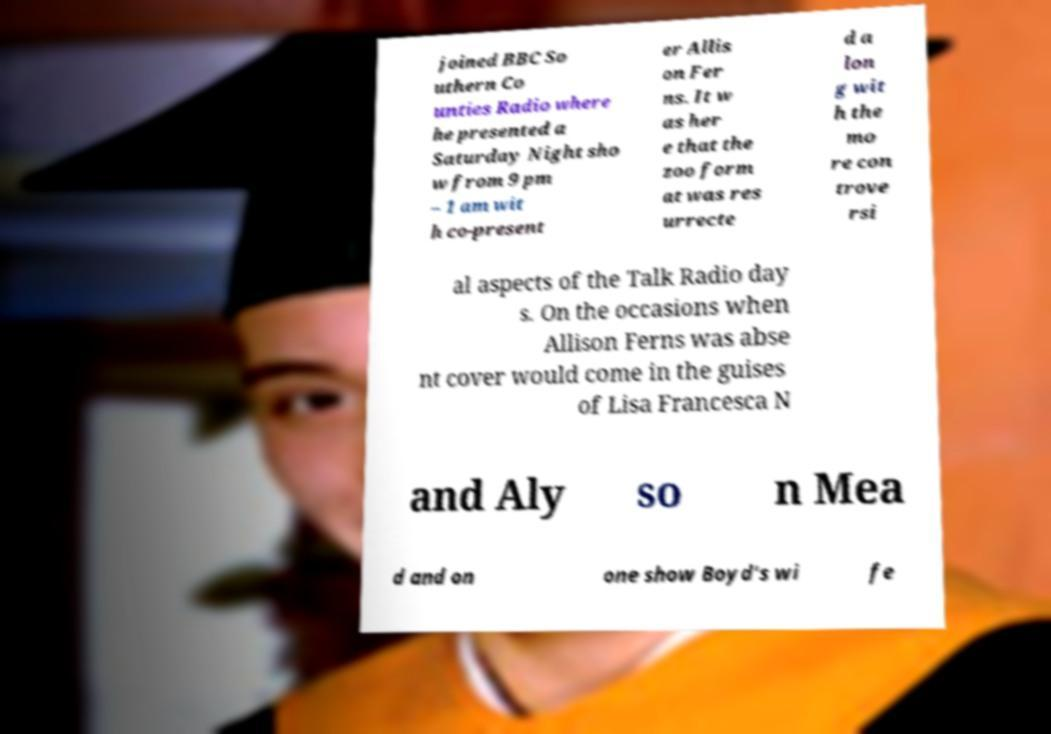Please read and relay the text visible in this image. What does it say? joined BBC So uthern Co unties Radio where he presented a Saturday Night sho w from 9 pm – 1 am wit h co-present er Allis on Fer ns. It w as her e that the zoo form at was res urrecte d a lon g wit h the mo re con trove rsi al aspects of the Talk Radio day s. On the occasions when Allison Ferns was abse nt cover would come in the guises of Lisa Francesca N and Aly so n Mea d and on one show Boyd's wi fe 